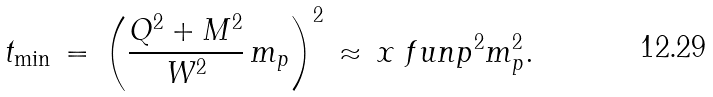<formula> <loc_0><loc_0><loc_500><loc_500>t _ { \min } \, = \, \left ( \frac { Q ^ { 2 } + M ^ { 2 } } { W ^ { 2 } } \, m _ { p } \right ) ^ { 2 } \, \approx \, x _ { \ } f u n p ^ { 2 } m _ { p } ^ { 2 } .</formula> 